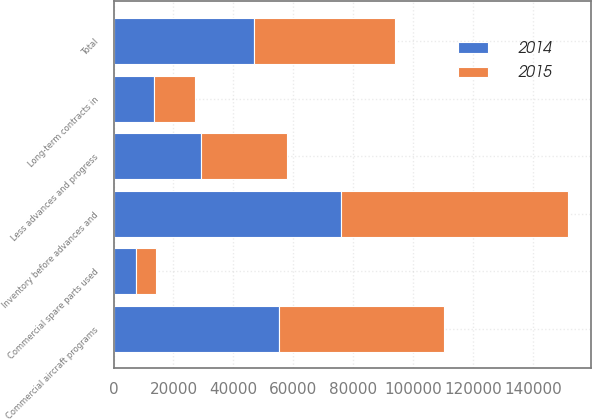Convert chart. <chart><loc_0><loc_0><loc_500><loc_500><stacked_bar_chart><ecel><fcel>Long-term contracts in<fcel>Commercial aircraft programs<fcel>Commercial spare parts used<fcel>Inventory before advances and<fcel>Less advances and progress<fcel>Total<nl><fcel>2015<fcel>13858<fcel>55230<fcel>6673<fcel>75761<fcel>28504<fcel>47257<nl><fcel>2014<fcel>13381<fcel>55220<fcel>7421<fcel>76022<fcel>29266<fcel>46756<nl></chart> 